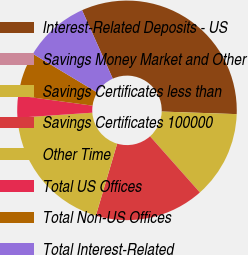Convert chart. <chart><loc_0><loc_0><loc_500><loc_500><pie_chart><fcel>Interest-Related Deposits - US<fcel>Savings Money Market and Other<fcel>Savings Certificates less than<fcel>Savings Certificates 100000<fcel>Other Time<fcel>Total US Offices<fcel>Total Non-US Offices<fcel>Total Interest-Related<nl><fcel>32.26%<fcel>0.0%<fcel>12.9%<fcel>16.13%<fcel>19.35%<fcel>3.23%<fcel>6.45%<fcel>9.68%<nl></chart> 